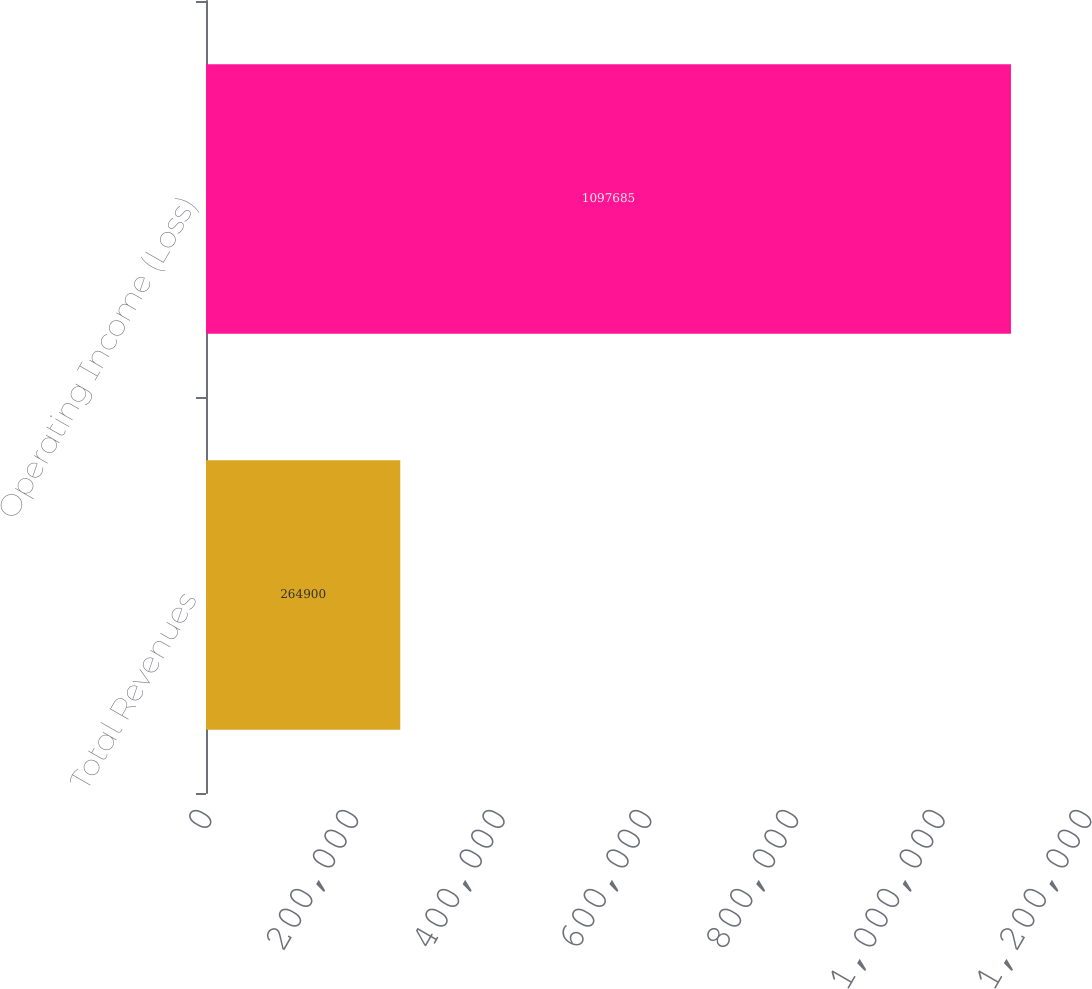Convert chart to OTSL. <chart><loc_0><loc_0><loc_500><loc_500><bar_chart><fcel>Total Revenues<fcel>Operating Income (Loss)<nl><fcel>264900<fcel>1.09768e+06<nl></chart> 